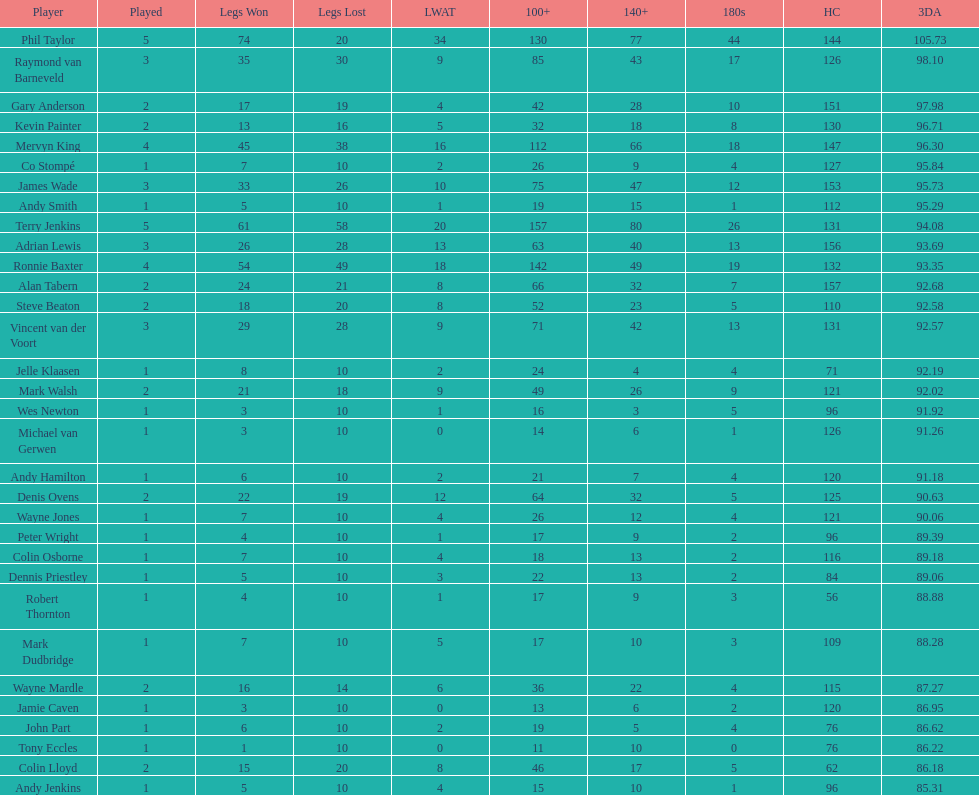Was andy smith or kevin painter's 3-dart average 96.71? Kevin Painter. 